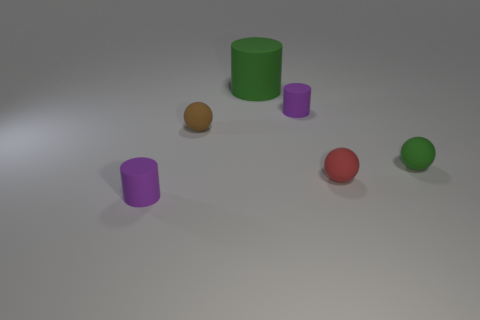Add 3 purple rubber cylinders. How many objects exist? 9 Subtract all large green cylinders. Subtract all purple things. How many objects are left? 3 Add 4 tiny brown matte things. How many tiny brown matte things are left? 5 Add 4 green cylinders. How many green cylinders exist? 5 Subtract 1 red balls. How many objects are left? 5 